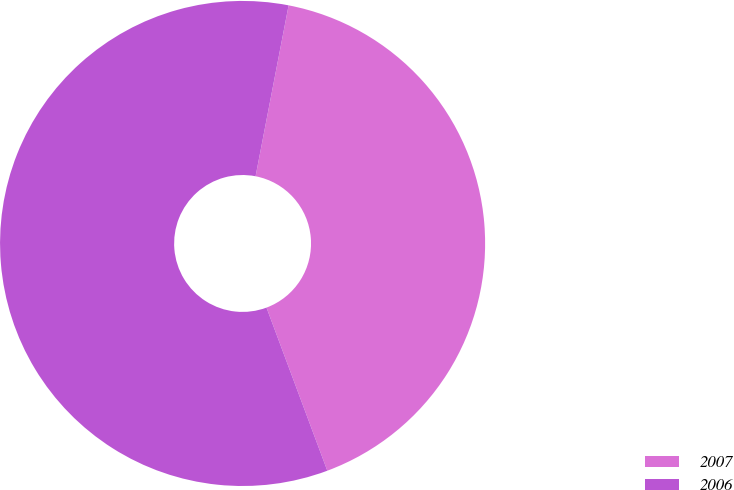Convert chart to OTSL. <chart><loc_0><loc_0><loc_500><loc_500><pie_chart><fcel>2007<fcel>2006<nl><fcel>41.28%<fcel>58.72%<nl></chart> 